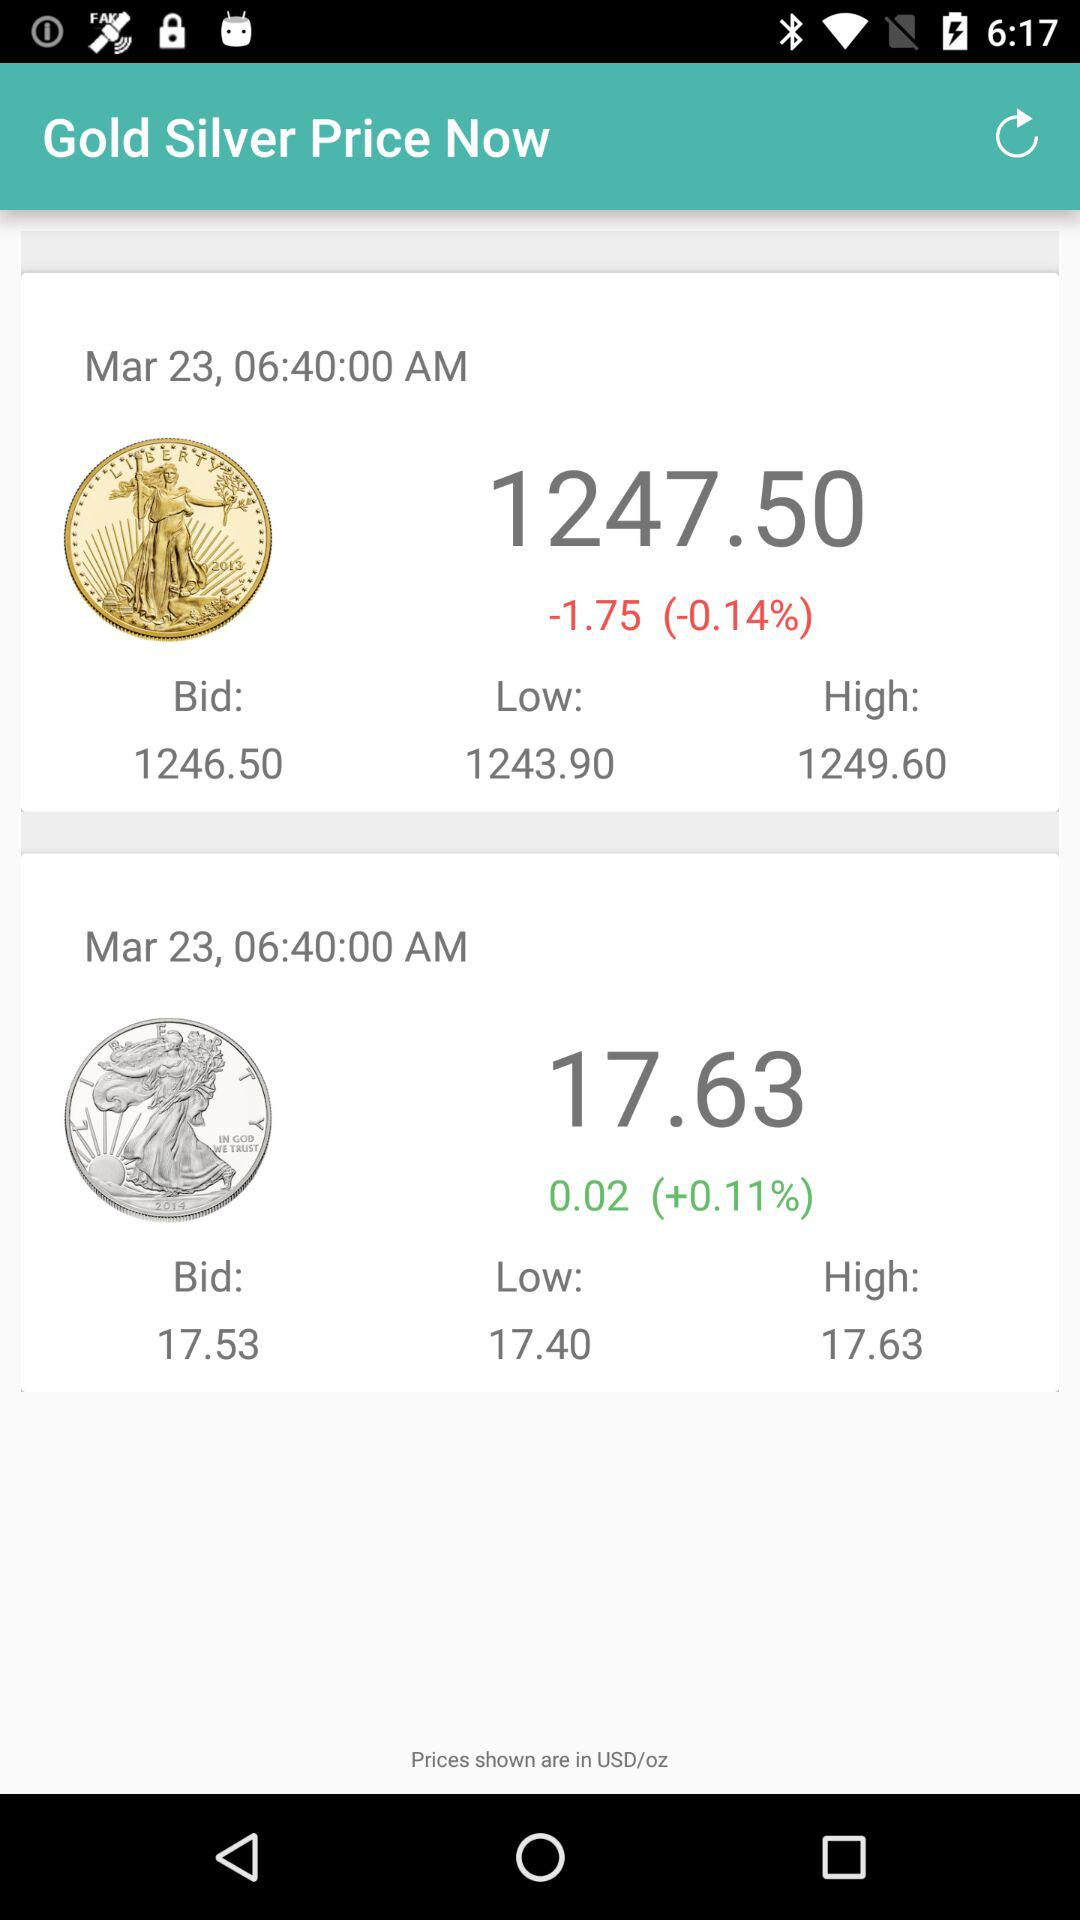What is the percentage change in the price of gold?
Answer the question using a single word or phrase. -0.14% 